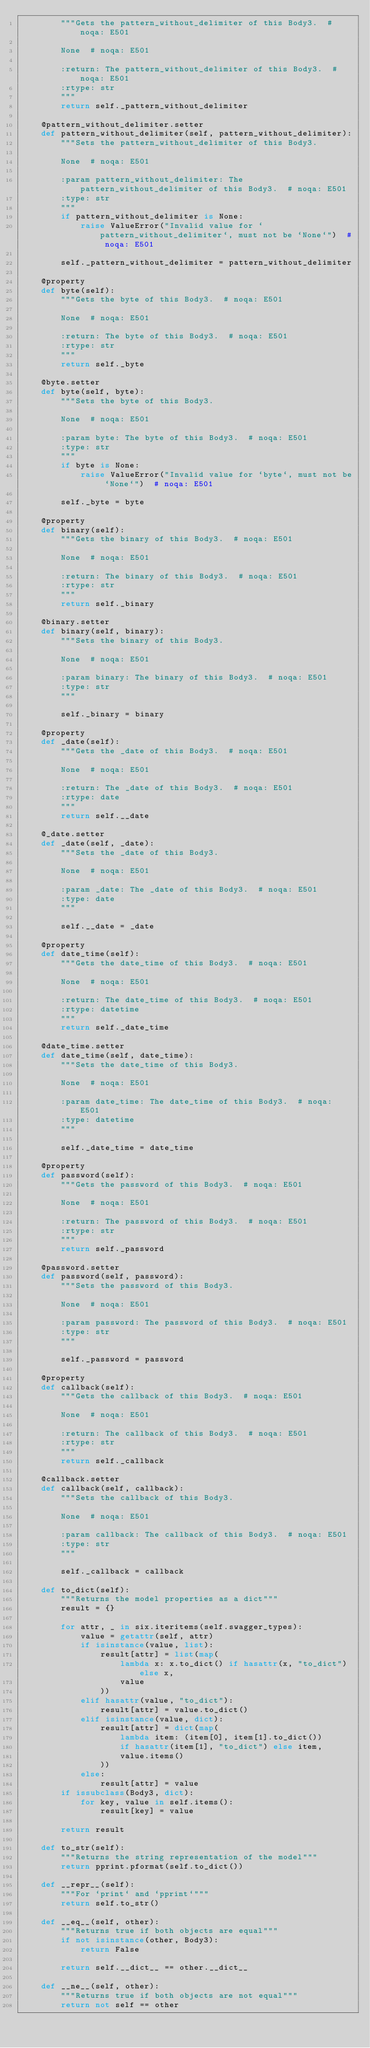<code> <loc_0><loc_0><loc_500><loc_500><_Python_>        """Gets the pattern_without_delimiter of this Body3.  # noqa: E501

        None  # noqa: E501

        :return: The pattern_without_delimiter of this Body3.  # noqa: E501
        :rtype: str
        """
        return self._pattern_without_delimiter

    @pattern_without_delimiter.setter
    def pattern_without_delimiter(self, pattern_without_delimiter):
        """Sets the pattern_without_delimiter of this Body3.

        None  # noqa: E501

        :param pattern_without_delimiter: The pattern_without_delimiter of this Body3.  # noqa: E501
        :type: str
        """
        if pattern_without_delimiter is None:
            raise ValueError("Invalid value for `pattern_without_delimiter`, must not be `None`")  # noqa: E501

        self._pattern_without_delimiter = pattern_without_delimiter

    @property
    def byte(self):
        """Gets the byte of this Body3.  # noqa: E501

        None  # noqa: E501

        :return: The byte of this Body3.  # noqa: E501
        :rtype: str
        """
        return self._byte

    @byte.setter
    def byte(self, byte):
        """Sets the byte of this Body3.

        None  # noqa: E501

        :param byte: The byte of this Body3.  # noqa: E501
        :type: str
        """
        if byte is None:
            raise ValueError("Invalid value for `byte`, must not be `None`")  # noqa: E501

        self._byte = byte

    @property
    def binary(self):
        """Gets the binary of this Body3.  # noqa: E501

        None  # noqa: E501

        :return: The binary of this Body3.  # noqa: E501
        :rtype: str
        """
        return self._binary

    @binary.setter
    def binary(self, binary):
        """Sets the binary of this Body3.

        None  # noqa: E501

        :param binary: The binary of this Body3.  # noqa: E501
        :type: str
        """

        self._binary = binary

    @property
    def _date(self):
        """Gets the _date of this Body3.  # noqa: E501

        None  # noqa: E501

        :return: The _date of this Body3.  # noqa: E501
        :rtype: date
        """
        return self.__date

    @_date.setter
    def _date(self, _date):
        """Sets the _date of this Body3.

        None  # noqa: E501

        :param _date: The _date of this Body3.  # noqa: E501
        :type: date
        """

        self.__date = _date

    @property
    def date_time(self):
        """Gets the date_time of this Body3.  # noqa: E501

        None  # noqa: E501

        :return: The date_time of this Body3.  # noqa: E501
        :rtype: datetime
        """
        return self._date_time

    @date_time.setter
    def date_time(self, date_time):
        """Sets the date_time of this Body3.

        None  # noqa: E501

        :param date_time: The date_time of this Body3.  # noqa: E501
        :type: datetime
        """

        self._date_time = date_time

    @property
    def password(self):
        """Gets the password of this Body3.  # noqa: E501

        None  # noqa: E501

        :return: The password of this Body3.  # noqa: E501
        :rtype: str
        """
        return self._password

    @password.setter
    def password(self, password):
        """Sets the password of this Body3.

        None  # noqa: E501

        :param password: The password of this Body3.  # noqa: E501
        :type: str
        """

        self._password = password

    @property
    def callback(self):
        """Gets the callback of this Body3.  # noqa: E501

        None  # noqa: E501

        :return: The callback of this Body3.  # noqa: E501
        :rtype: str
        """
        return self._callback

    @callback.setter
    def callback(self, callback):
        """Sets the callback of this Body3.

        None  # noqa: E501

        :param callback: The callback of this Body3.  # noqa: E501
        :type: str
        """

        self._callback = callback

    def to_dict(self):
        """Returns the model properties as a dict"""
        result = {}

        for attr, _ in six.iteritems(self.swagger_types):
            value = getattr(self, attr)
            if isinstance(value, list):
                result[attr] = list(map(
                    lambda x: x.to_dict() if hasattr(x, "to_dict") else x,
                    value
                ))
            elif hasattr(value, "to_dict"):
                result[attr] = value.to_dict()
            elif isinstance(value, dict):
                result[attr] = dict(map(
                    lambda item: (item[0], item[1].to_dict())
                    if hasattr(item[1], "to_dict") else item,
                    value.items()
                ))
            else:
                result[attr] = value
        if issubclass(Body3, dict):
            for key, value in self.items():
                result[key] = value

        return result

    def to_str(self):
        """Returns the string representation of the model"""
        return pprint.pformat(self.to_dict())

    def __repr__(self):
        """For `print` and `pprint`"""
        return self.to_str()

    def __eq__(self, other):
        """Returns true if both objects are equal"""
        if not isinstance(other, Body3):
            return False

        return self.__dict__ == other.__dict__

    def __ne__(self, other):
        """Returns true if both objects are not equal"""
        return not self == other
</code> 